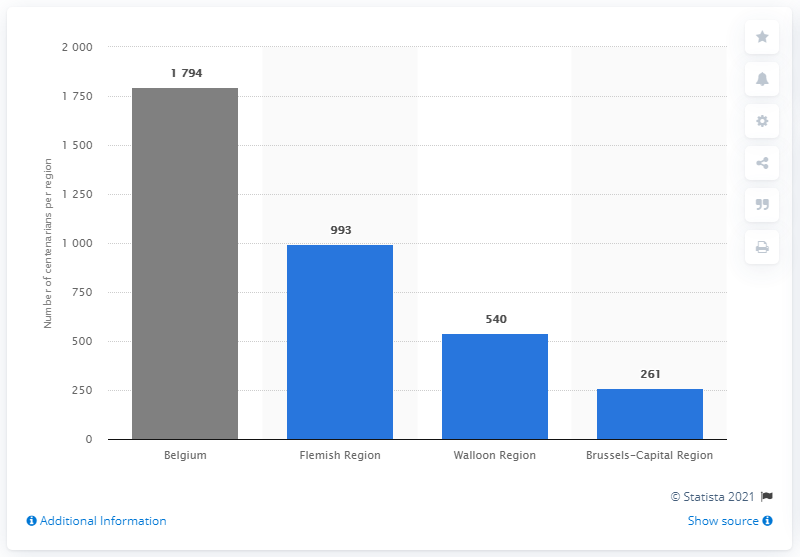Mention a couple of crucial points in this snapshot. In 2020, there were 540 centenarians who lived in the Walloon region. In the Flemish region in 2020, there were 993 centenarians who were alive. 